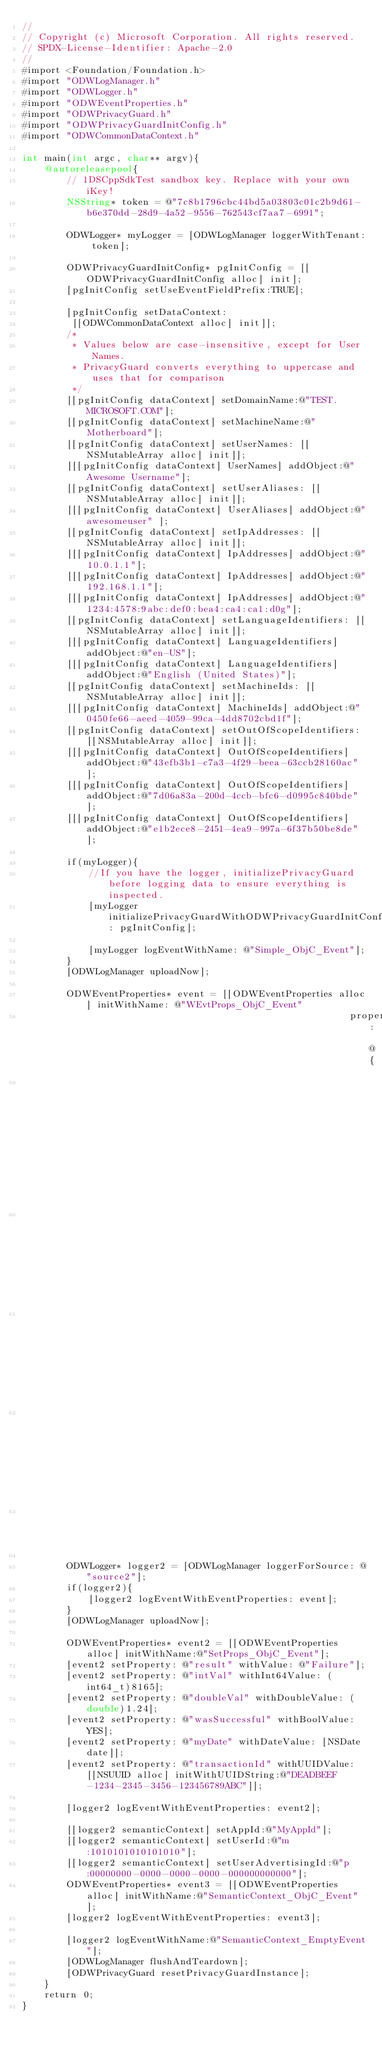Convert code to text. <code><loc_0><loc_0><loc_500><loc_500><_ObjectiveC_>//
// Copyright (c) Microsoft Corporation. All rights reserved.
// SPDX-License-Identifier: Apache-2.0
//
#import <Foundation/Foundation.h>
#import "ODWLogManager.h"
#import "ODWLogger.h"
#import "ODWEventProperties.h"
#import "ODWPrivacyGuard.h"
#import "ODWPrivacyGuardInitConfig.h"
#import "ODWCommonDataContext.h"

int main(int argc, char** argv){
    @autoreleasepool{
        // 1DSCppSdkTest sandbox key. Replace with your own iKey!
        NSString* token = @"7c8b1796cbc44bd5a03803c01c2b9d61-b6e370dd-28d9-4a52-9556-762543cf7aa7-6991";

        ODWLogger* myLogger = [ODWLogManager loggerWithTenant: token];

        ODWPrivacyGuardInitConfig* pgInitConfig = [[ODWPrivacyGuardInitConfig alloc] init];
		[pgInitConfig setUseEventFieldPrefix:TRUE];

        [pgInitConfig setDataContext:
		 [[ODWCommonDataContext alloc] init]];
        /*
         * Values below are case-insensitive, except for User Names.
         * PrivacyGuard converts everything to uppercase and uses that for comparison
         */
        [[pgInitConfig dataContext] setDomainName:@"TEST.MICROSOFT.COM"];
        [[pgInitConfig dataContext] setMachineName:@"Motherboard"];
        [[pgInitConfig dataContext] setUserNames: [[NSMutableArray alloc] init]];
        [[[pgInitConfig dataContext] UserNames] addObject:@"Awesome Username"];
        [[pgInitConfig dataContext] setUserAliases: [[NSMutableArray alloc] init]];
        [[[pgInitConfig dataContext] UserAliases] addObject:@"awesomeuser" ];
        [[pgInitConfig dataContext] setIpAddresses: [[NSMutableArray alloc] init]];
        [[[pgInitConfig dataContext] IpAddresses] addObject:@"10.0.1.1"];
        [[[pgInitConfig dataContext] IpAddresses] addObject:@"192.168.1.1"];
        [[[pgInitConfig dataContext] IpAddresses] addObject:@"1234:4578:9abc:def0:bea4:ca4:ca1:d0g"];
        [[pgInitConfig dataContext] setLanguageIdentifiers: [[NSMutableArray alloc] init]];
        [[[pgInitConfig dataContext] LanguageIdentifiers] addObject:@"en-US"];
        [[[pgInitConfig dataContext] LanguageIdentifiers] addObject:@"English (United States)"];
        [[pgInitConfig dataContext] setMachineIds: [[NSMutableArray alloc] init]];
        [[[pgInitConfig dataContext] MachineIds] addObject:@"0450fe66-aeed-4059-99ca-4dd8702cbd1f"];
        [[pgInitConfig dataContext] setOutOfScopeIdentifiers: [[NSMutableArray alloc] init]];
        [[[pgInitConfig dataContext] OutOfScopeIdentifiers] addObject:@"43efb3b1-c7a3-4f29-beea-63ccb28160ac"];
        [[[pgInitConfig dataContext] OutOfScopeIdentifiers] addObject:@"7d06a83a-200d-4ccb-bfc6-d0995c840bde"];
        [[[pgInitConfig dataContext] OutOfScopeIdentifiers] addObject:@"e1b2ece8-2451-4ea9-997a-6f37b50be8de"];

        if(myLogger){
            //If you have the logger, initializePrivacyGuard before logging data to ensure everything is inspected.
            [myLogger initializePrivacyGuardWithODWPrivacyGuardInitConfig: pgInitConfig];

            [myLogger logEventWithName: @"Simple_ObjC_Event"];
        }
        [ODWLogManager uploadNow];

        ODWEventProperties* event = [[ODWEventProperties alloc] initWithName: @"WEvtProps_ObjC_Event"
                                                           properties: @{
                                                                            @"result": @"Success", 
                                                                            @"seq": @2, 
                                                                            @"random": @3,
                                                                            @"secret": @5.75 
                                                                            } ];

        ODWLogger* logger2 = [ODWLogManager loggerForSource: @"source2"];
        if(logger2){
            [logger2 logEventWithEventProperties: event];
        }
        [ODWLogManager uploadNow];

        ODWEventProperties* event2 = [[ODWEventProperties alloc] initWithName:@"SetProps_ObjC_Event"];
        [event2 setProperty: @"result" withValue: @"Failure"];
        [event2 setProperty: @"intVal" withInt64Value: (int64_t)8165];
        [event2 setProperty: @"doubleVal" withDoubleValue: (double)1.24];
        [event2 setProperty: @"wasSuccessful" withBoolValue: YES];
        [event2 setProperty: @"myDate" withDateValue: [NSDate date]];
        [event2 setProperty: @"transactionId" withUUIDValue: [[NSUUID alloc] initWithUUIDString:@"DEADBEEF-1234-2345-3456-123456789ABC"]];

        [logger2 logEventWithEventProperties: event2];

        [[logger2 semanticContext] setAppId:@"MyAppId"];
        [[logger2 semanticContext] setUserId:@"m:1010101010101010"];
        [[logger2 semanticContext] setUserAdvertisingId:@"p:00000000-0000-0000-0000-000000000000"];
        ODWEventProperties* event3 = [[ODWEventProperties alloc] initWithName:@"SemanticContext_ObjC_Event"];
        [logger2 logEventWithEventProperties: event3];

        [logger2 logEventWithName:@"SemanticContext_EmptyEvent"];
        [ODWLogManager flushAndTeardown];
        [ODWPrivacyGuard resetPrivacyGuardInstance];
    }
    return 0;
}
</code> 